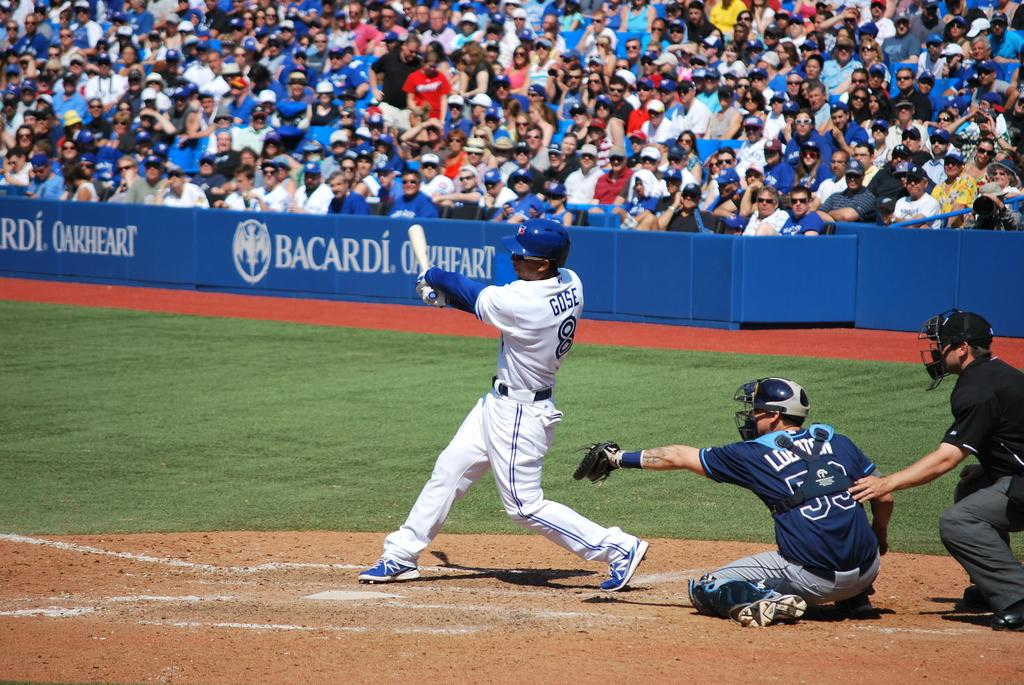<image>
Render a clear and concise summary of the photo. A sellout baseball game sponsered by Bacardi Oakheart. 